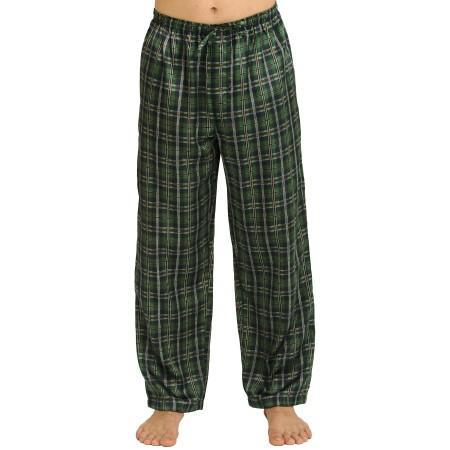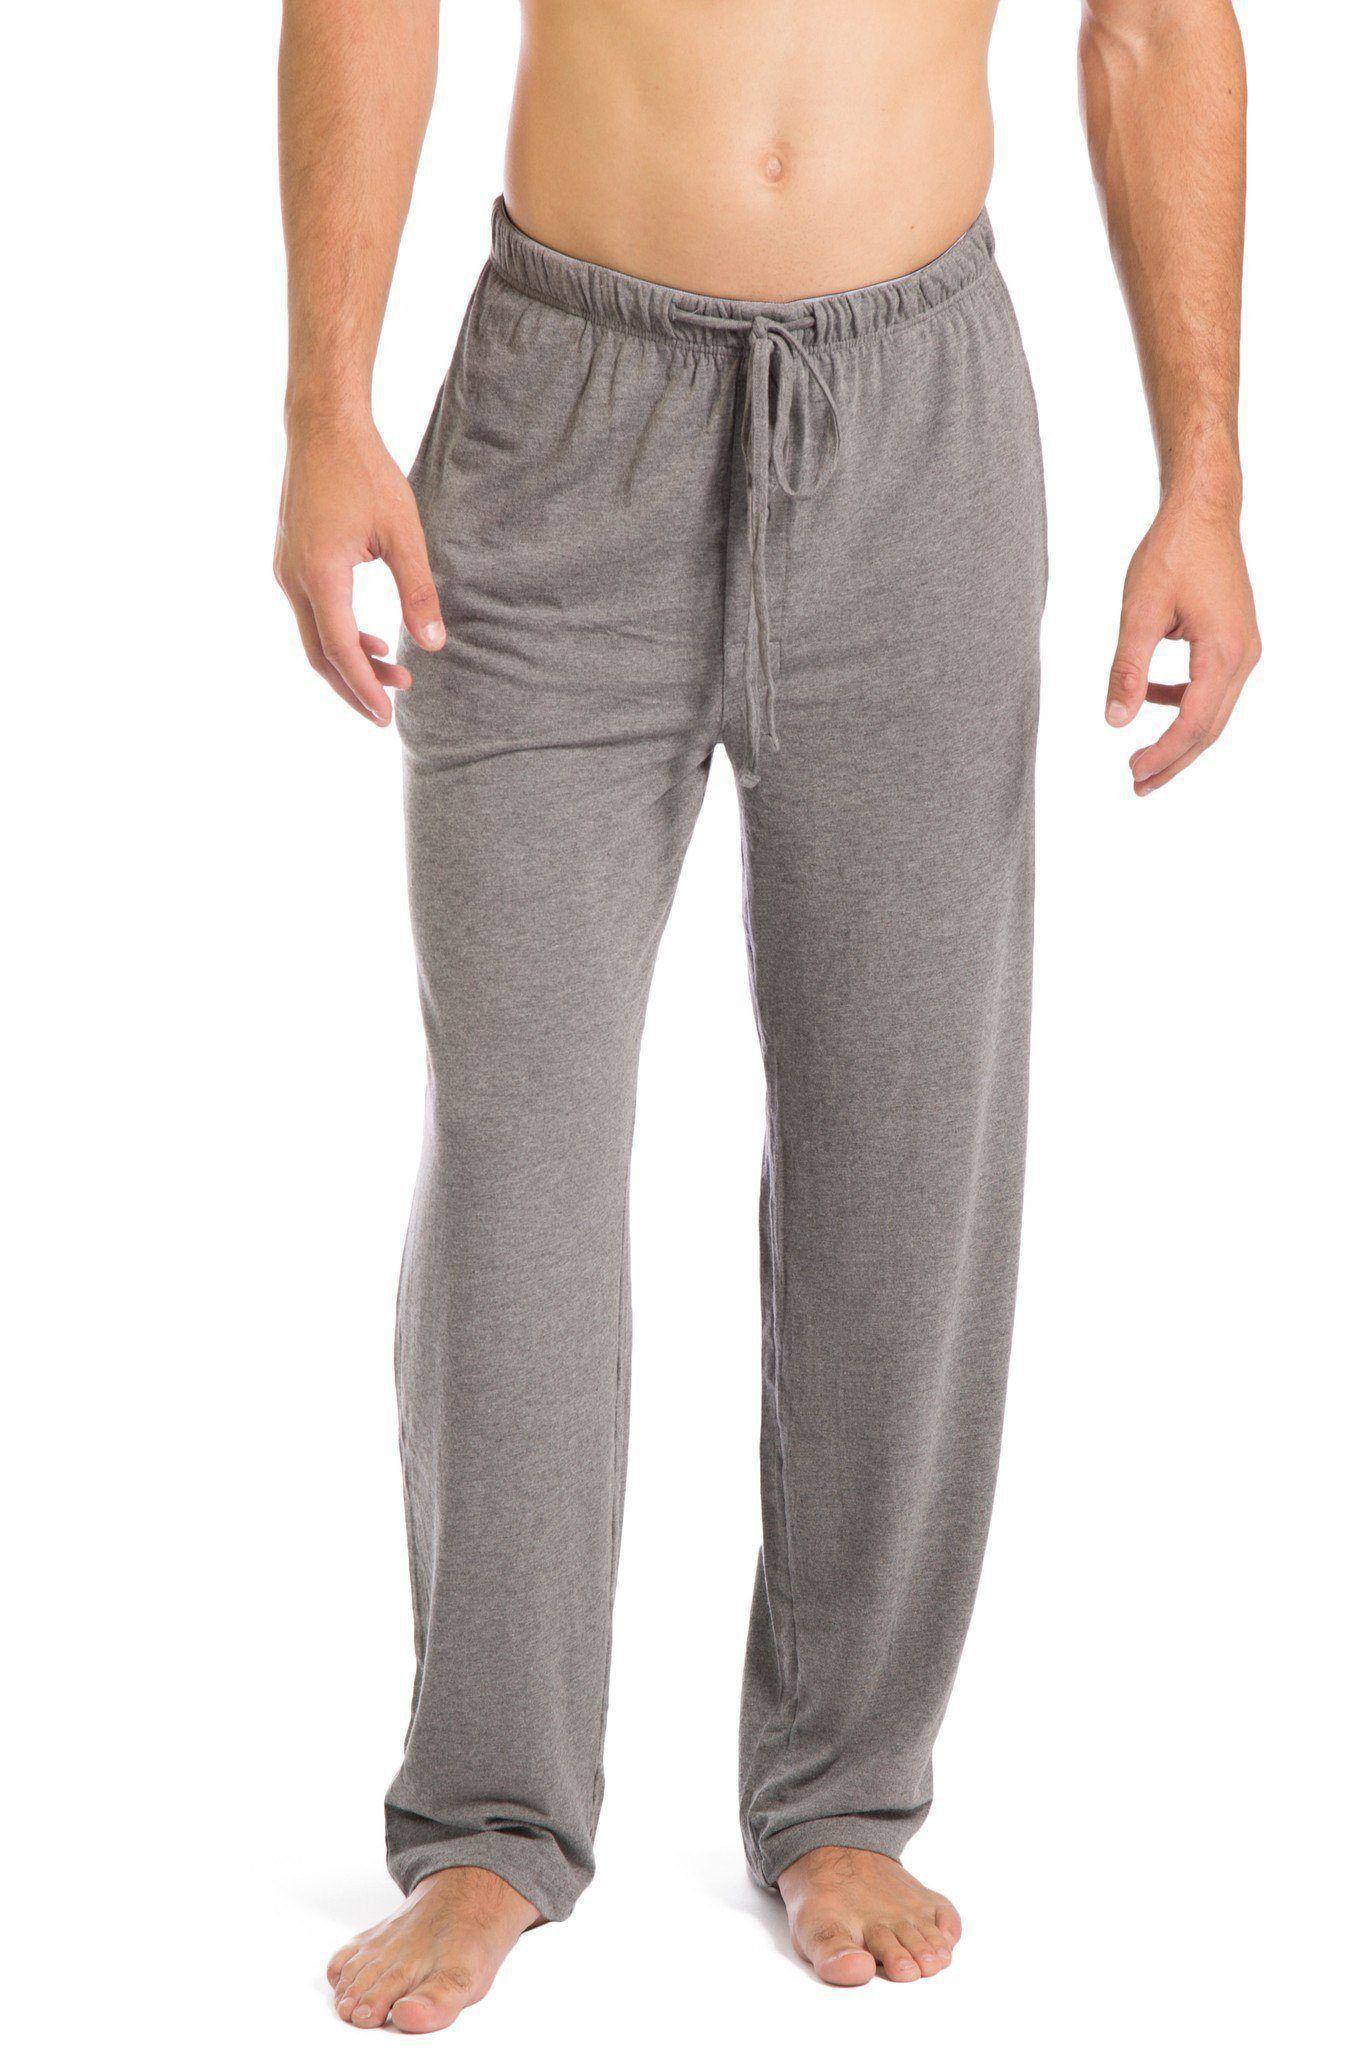The first image is the image on the left, the second image is the image on the right. Considering the images on both sides, is "One pair of pajama pants is a solid color." valid? Answer yes or no. Yes. 